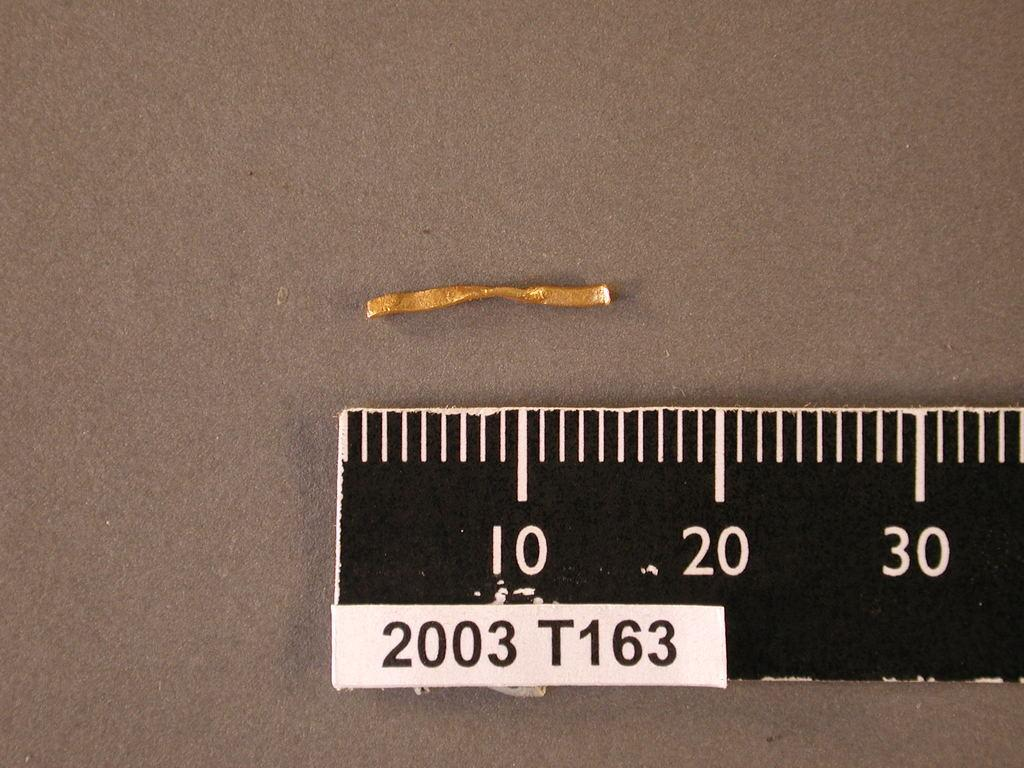<image>
Render a clear and concise summary of the photo. Ruler 2003 T163 is being used to measure a small piece of wire. 